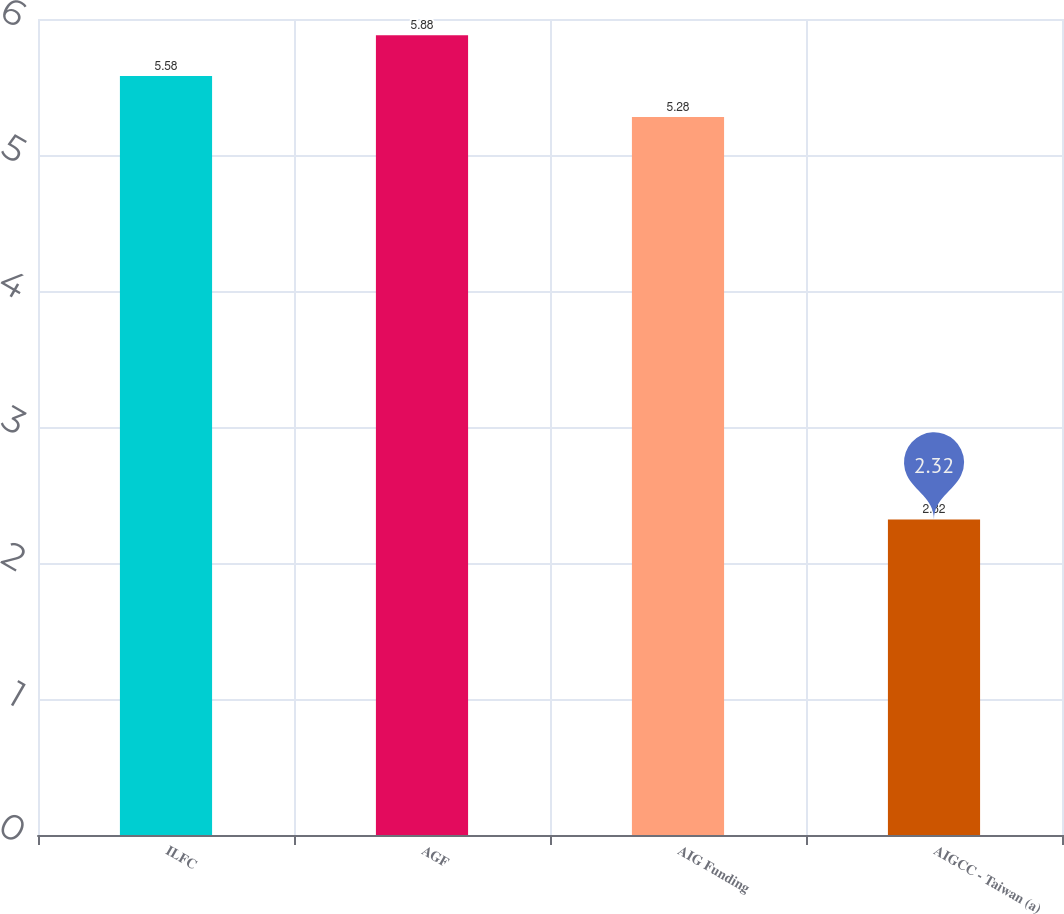<chart> <loc_0><loc_0><loc_500><loc_500><bar_chart><fcel>ILFC<fcel>AGF<fcel>AIG Funding<fcel>AIGCC - Taiwan (a)<nl><fcel>5.58<fcel>5.88<fcel>5.28<fcel>2.32<nl></chart> 